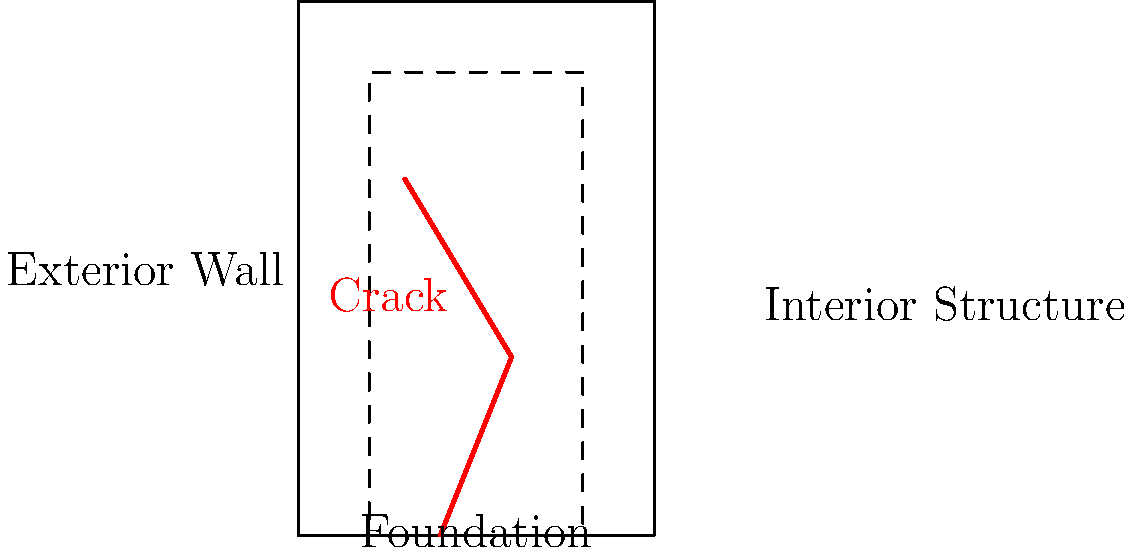A structural engineer is assessing the integrity of an older building in downtown Albuquerque. The simplified cross-section diagram shows a crack in the structure. If the crack width at the foundation level is 0.3 inches and increases by 0.02 inches every 10 feet in height, what is the approximate crack width at the top of the 50-foot tall building? To solve this problem, we need to follow these steps:

1. Understand the given information:
   - The building is 50 feet tall
   - The crack width at the foundation is 0.3 inches
   - The crack width increases by 0.02 inches every 10 feet in height

2. Calculate how many 10-foot sections are in the 50-foot tall building:
   $$ \text{Number of sections} = \frac{\text{Building height}}{\text{Section height}} = \frac{50 \text{ feet}}{10 \text{ feet}} = 5 \text{ sections} $$

3. Calculate the total increase in crack width:
   $$ \text{Total increase} = \text{Increase per section} \times \text{Number of sections} $$
   $$ \text{Total increase} = 0.02 \text{ inches} \times 5 = 0.1 \text{ inches} $$

4. Add the initial crack width to the total increase:
   $$ \text{Final crack width} = \text{Initial width} + \text{Total increase} $$
   $$ \text{Final crack width} = 0.3 \text{ inches} + 0.1 \text{ inches} = 0.4 \text{ inches} $$

Therefore, the approximate crack width at the top of the 50-foot tall building is 0.4 inches.
Answer: 0.4 inches 